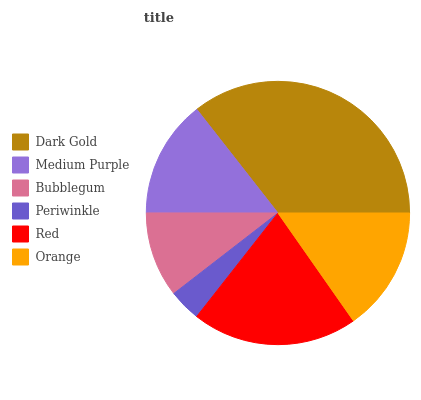Is Periwinkle the minimum?
Answer yes or no. Yes. Is Dark Gold the maximum?
Answer yes or no. Yes. Is Medium Purple the minimum?
Answer yes or no. No. Is Medium Purple the maximum?
Answer yes or no. No. Is Dark Gold greater than Medium Purple?
Answer yes or no. Yes. Is Medium Purple less than Dark Gold?
Answer yes or no. Yes. Is Medium Purple greater than Dark Gold?
Answer yes or no. No. Is Dark Gold less than Medium Purple?
Answer yes or no. No. Is Orange the high median?
Answer yes or no. Yes. Is Medium Purple the low median?
Answer yes or no. Yes. Is Medium Purple the high median?
Answer yes or no. No. Is Bubblegum the low median?
Answer yes or no. No. 